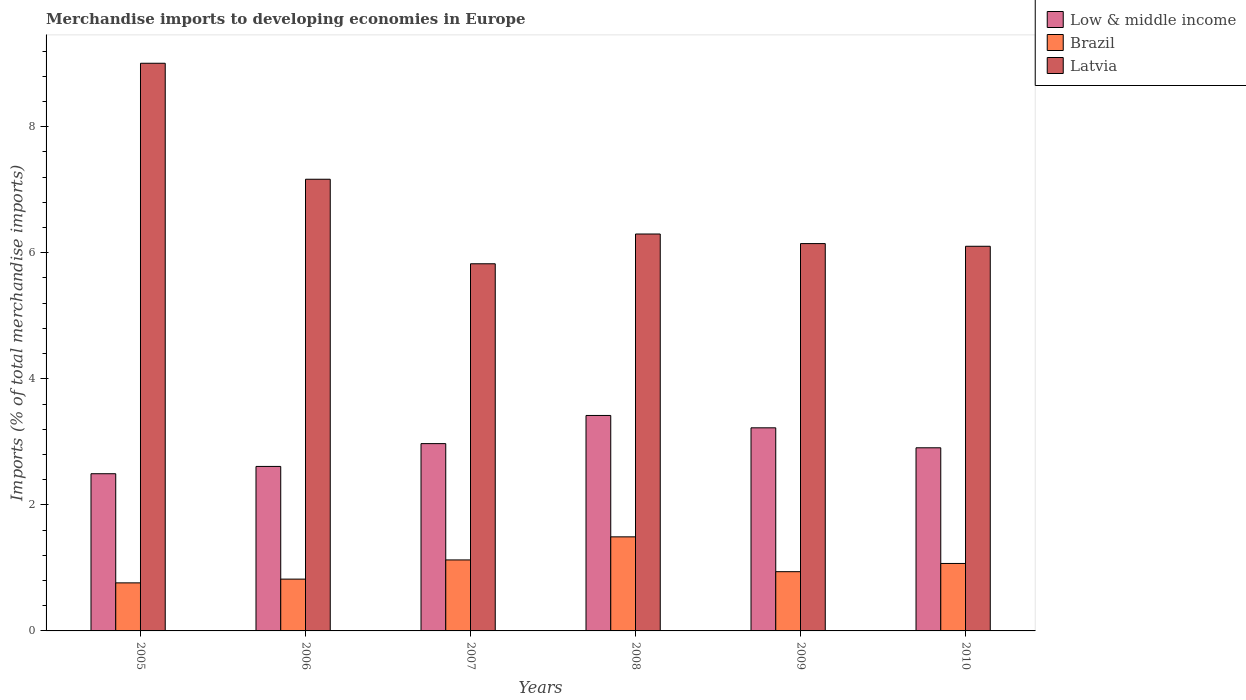How many groups of bars are there?
Give a very brief answer. 6. Are the number of bars per tick equal to the number of legend labels?
Your answer should be compact. Yes. How many bars are there on the 5th tick from the left?
Your answer should be very brief. 3. How many bars are there on the 2nd tick from the right?
Provide a short and direct response. 3. In how many cases, is the number of bars for a given year not equal to the number of legend labels?
Keep it short and to the point. 0. What is the percentage total merchandise imports in Latvia in 2009?
Your answer should be very brief. 6.15. Across all years, what is the maximum percentage total merchandise imports in Latvia?
Provide a succinct answer. 9.01. Across all years, what is the minimum percentage total merchandise imports in Brazil?
Your answer should be very brief. 0.76. In which year was the percentage total merchandise imports in Low & middle income maximum?
Make the answer very short. 2008. In which year was the percentage total merchandise imports in Latvia minimum?
Give a very brief answer. 2007. What is the total percentage total merchandise imports in Latvia in the graph?
Provide a succinct answer. 40.55. What is the difference between the percentage total merchandise imports in Brazil in 2006 and that in 2007?
Offer a terse response. -0.3. What is the difference between the percentage total merchandise imports in Brazil in 2007 and the percentage total merchandise imports in Low & middle income in 2008?
Make the answer very short. -2.29. What is the average percentage total merchandise imports in Latvia per year?
Your response must be concise. 6.76. In the year 2009, what is the difference between the percentage total merchandise imports in Low & middle income and percentage total merchandise imports in Brazil?
Give a very brief answer. 2.28. In how many years, is the percentage total merchandise imports in Brazil greater than 1.6 %?
Offer a very short reply. 0. What is the ratio of the percentage total merchandise imports in Low & middle income in 2007 to that in 2008?
Provide a short and direct response. 0.87. What is the difference between the highest and the second highest percentage total merchandise imports in Low & middle income?
Offer a very short reply. 0.2. What is the difference between the highest and the lowest percentage total merchandise imports in Brazil?
Your answer should be very brief. 0.73. In how many years, is the percentage total merchandise imports in Latvia greater than the average percentage total merchandise imports in Latvia taken over all years?
Provide a succinct answer. 2. What does the 2nd bar from the left in 2009 represents?
Provide a short and direct response. Brazil. What does the 3rd bar from the right in 2009 represents?
Your answer should be very brief. Low & middle income. Is it the case that in every year, the sum of the percentage total merchandise imports in Latvia and percentage total merchandise imports in Low & middle income is greater than the percentage total merchandise imports in Brazil?
Offer a terse response. Yes. How many years are there in the graph?
Give a very brief answer. 6. Does the graph contain any zero values?
Your answer should be very brief. No. Does the graph contain grids?
Offer a terse response. No. What is the title of the graph?
Keep it short and to the point. Merchandise imports to developing economies in Europe. What is the label or title of the X-axis?
Your answer should be compact. Years. What is the label or title of the Y-axis?
Keep it short and to the point. Imports (% of total merchandise imports). What is the Imports (% of total merchandise imports) in Low & middle income in 2005?
Provide a short and direct response. 2.49. What is the Imports (% of total merchandise imports) of Brazil in 2005?
Keep it short and to the point. 0.76. What is the Imports (% of total merchandise imports) in Latvia in 2005?
Ensure brevity in your answer.  9.01. What is the Imports (% of total merchandise imports) in Low & middle income in 2006?
Ensure brevity in your answer.  2.61. What is the Imports (% of total merchandise imports) in Brazil in 2006?
Your answer should be very brief. 0.82. What is the Imports (% of total merchandise imports) of Latvia in 2006?
Ensure brevity in your answer.  7.17. What is the Imports (% of total merchandise imports) in Low & middle income in 2007?
Make the answer very short. 2.97. What is the Imports (% of total merchandise imports) of Brazil in 2007?
Your response must be concise. 1.13. What is the Imports (% of total merchandise imports) of Latvia in 2007?
Offer a terse response. 5.83. What is the Imports (% of total merchandise imports) in Low & middle income in 2008?
Provide a succinct answer. 3.42. What is the Imports (% of total merchandise imports) in Brazil in 2008?
Provide a short and direct response. 1.49. What is the Imports (% of total merchandise imports) in Latvia in 2008?
Offer a terse response. 6.3. What is the Imports (% of total merchandise imports) of Low & middle income in 2009?
Your answer should be compact. 3.22. What is the Imports (% of total merchandise imports) in Brazil in 2009?
Keep it short and to the point. 0.94. What is the Imports (% of total merchandise imports) of Latvia in 2009?
Offer a terse response. 6.15. What is the Imports (% of total merchandise imports) of Low & middle income in 2010?
Your answer should be very brief. 2.91. What is the Imports (% of total merchandise imports) of Brazil in 2010?
Your answer should be very brief. 1.07. What is the Imports (% of total merchandise imports) of Latvia in 2010?
Give a very brief answer. 6.1. Across all years, what is the maximum Imports (% of total merchandise imports) in Low & middle income?
Make the answer very short. 3.42. Across all years, what is the maximum Imports (% of total merchandise imports) in Brazil?
Give a very brief answer. 1.49. Across all years, what is the maximum Imports (% of total merchandise imports) of Latvia?
Give a very brief answer. 9.01. Across all years, what is the minimum Imports (% of total merchandise imports) of Low & middle income?
Your answer should be compact. 2.49. Across all years, what is the minimum Imports (% of total merchandise imports) in Brazil?
Give a very brief answer. 0.76. Across all years, what is the minimum Imports (% of total merchandise imports) of Latvia?
Your response must be concise. 5.83. What is the total Imports (% of total merchandise imports) in Low & middle income in the graph?
Provide a succinct answer. 17.62. What is the total Imports (% of total merchandise imports) of Brazil in the graph?
Your answer should be very brief. 6.21. What is the total Imports (% of total merchandise imports) of Latvia in the graph?
Keep it short and to the point. 40.55. What is the difference between the Imports (% of total merchandise imports) of Low & middle income in 2005 and that in 2006?
Keep it short and to the point. -0.12. What is the difference between the Imports (% of total merchandise imports) of Brazil in 2005 and that in 2006?
Make the answer very short. -0.06. What is the difference between the Imports (% of total merchandise imports) of Latvia in 2005 and that in 2006?
Give a very brief answer. 1.84. What is the difference between the Imports (% of total merchandise imports) in Low & middle income in 2005 and that in 2007?
Your answer should be compact. -0.48. What is the difference between the Imports (% of total merchandise imports) in Brazil in 2005 and that in 2007?
Ensure brevity in your answer.  -0.36. What is the difference between the Imports (% of total merchandise imports) of Latvia in 2005 and that in 2007?
Keep it short and to the point. 3.18. What is the difference between the Imports (% of total merchandise imports) in Low & middle income in 2005 and that in 2008?
Keep it short and to the point. -0.92. What is the difference between the Imports (% of total merchandise imports) in Brazil in 2005 and that in 2008?
Your answer should be compact. -0.73. What is the difference between the Imports (% of total merchandise imports) of Latvia in 2005 and that in 2008?
Your answer should be compact. 2.71. What is the difference between the Imports (% of total merchandise imports) of Low & middle income in 2005 and that in 2009?
Offer a very short reply. -0.73. What is the difference between the Imports (% of total merchandise imports) in Brazil in 2005 and that in 2009?
Make the answer very short. -0.18. What is the difference between the Imports (% of total merchandise imports) in Latvia in 2005 and that in 2009?
Provide a short and direct response. 2.86. What is the difference between the Imports (% of total merchandise imports) of Low & middle income in 2005 and that in 2010?
Your answer should be compact. -0.41. What is the difference between the Imports (% of total merchandise imports) of Brazil in 2005 and that in 2010?
Keep it short and to the point. -0.31. What is the difference between the Imports (% of total merchandise imports) of Latvia in 2005 and that in 2010?
Ensure brevity in your answer.  2.9. What is the difference between the Imports (% of total merchandise imports) in Low & middle income in 2006 and that in 2007?
Give a very brief answer. -0.36. What is the difference between the Imports (% of total merchandise imports) in Brazil in 2006 and that in 2007?
Provide a succinct answer. -0.3. What is the difference between the Imports (% of total merchandise imports) in Latvia in 2006 and that in 2007?
Give a very brief answer. 1.34. What is the difference between the Imports (% of total merchandise imports) in Low & middle income in 2006 and that in 2008?
Your response must be concise. -0.81. What is the difference between the Imports (% of total merchandise imports) in Brazil in 2006 and that in 2008?
Offer a terse response. -0.67. What is the difference between the Imports (% of total merchandise imports) in Latvia in 2006 and that in 2008?
Ensure brevity in your answer.  0.87. What is the difference between the Imports (% of total merchandise imports) of Low & middle income in 2006 and that in 2009?
Your answer should be very brief. -0.61. What is the difference between the Imports (% of total merchandise imports) in Brazil in 2006 and that in 2009?
Your answer should be compact. -0.12. What is the difference between the Imports (% of total merchandise imports) in Latvia in 2006 and that in 2009?
Your answer should be very brief. 1.02. What is the difference between the Imports (% of total merchandise imports) of Low & middle income in 2006 and that in 2010?
Provide a short and direct response. -0.3. What is the difference between the Imports (% of total merchandise imports) of Brazil in 2006 and that in 2010?
Offer a terse response. -0.25. What is the difference between the Imports (% of total merchandise imports) of Latvia in 2006 and that in 2010?
Ensure brevity in your answer.  1.06. What is the difference between the Imports (% of total merchandise imports) of Low & middle income in 2007 and that in 2008?
Provide a succinct answer. -0.45. What is the difference between the Imports (% of total merchandise imports) of Brazil in 2007 and that in 2008?
Offer a very short reply. -0.37. What is the difference between the Imports (% of total merchandise imports) in Latvia in 2007 and that in 2008?
Your answer should be compact. -0.47. What is the difference between the Imports (% of total merchandise imports) of Low & middle income in 2007 and that in 2009?
Provide a succinct answer. -0.25. What is the difference between the Imports (% of total merchandise imports) in Brazil in 2007 and that in 2009?
Make the answer very short. 0.19. What is the difference between the Imports (% of total merchandise imports) in Latvia in 2007 and that in 2009?
Provide a short and direct response. -0.32. What is the difference between the Imports (% of total merchandise imports) of Low & middle income in 2007 and that in 2010?
Make the answer very short. 0.07. What is the difference between the Imports (% of total merchandise imports) in Brazil in 2007 and that in 2010?
Give a very brief answer. 0.06. What is the difference between the Imports (% of total merchandise imports) in Latvia in 2007 and that in 2010?
Make the answer very short. -0.28. What is the difference between the Imports (% of total merchandise imports) of Low & middle income in 2008 and that in 2009?
Your answer should be very brief. 0.2. What is the difference between the Imports (% of total merchandise imports) of Brazil in 2008 and that in 2009?
Give a very brief answer. 0.55. What is the difference between the Imports (% of total merchandise imports) of Latvia in 2008 and that in 2009?
Ensure brevity in your answer.  0.15. What is the difference between the Imports (% of total merchandise imports) of Low & middle income in 2008 and that in 2010?
Keep it short and to the point. 0.51. What is the difference between the Imports (% of total merchandise imports) of Brazil in 2008 and that in 2010?
Make the answer very short. 0.42. What is the difference between the Imports (% of total merchandise imports) of Latvia in 2008 and that in 2010?
Provide a short and direct response. 0.19. What is the difference between the Imports (% of total merchandise imports) in Low & middle income in 2009 and that in 2010?
Your response must be concise. 0.32. What is the difference between the Imports (% of total merchandise imports) of Brazil in 2009 and that in 2010?
Give a very brief answer. -0.13. What is the difference between the Imports (% of total merchandise imports) in Latvia in 2009 and that in 2010?
Offer a very short reply. 0.04. What is the difference between the Imports (% of total merchandise imports) in Low & middle income in 2005 and the Imports (% of total merchandise imports) in Brazil in 2006?
Your response must be concise. 1.67. What is the difference between the Imports (% of total merchandise imports) in Low & middle income in 2005 and the Imports (% of total merchandise imports) in Latvia in 2006?
Your answer should be compact. -4.67. What is the difference between the Imports (% of total merchandise imports) in Brazil in 2005 and the Imports (% of total merchandise imports) in Latvia in 2006?
Your answer should be compact. -6.4. What is the difference between the Imports (% of total merchandise imports) in Low & middle income in 2005 and the Imports (% of total merchandise imports) in Brazil in 2007?
Make the answer very short. 1.37. What is the difference between the Imports (% of total merchandise imports) of Low & middle income in 2005 and the Imports (% of total merchandise imports) of Latvia in 2007?
Your answer should be very brief. -3.33. What is the difference between the Imports (% of total merchandise imports) of Brazil in 2005 and the Imports (% of total merchandise imports) of Latvia in 2007?
Your answer should be very brief. -5.06. What is the difference between the Imports (% of total merchandise imports) of Low & middle income in 2005 and the Imports (% of total merchandise imports) of Latvia in 2008?
Offer a terse response. -3.8. What is the difference between the Imports (% of total merchandise imports) of Brazil in 2005 and the Imports (% of total merchandise imports) of Latvia in 2008?
Your answer should be compact. -5.54. What is the difference between the Imports (% of total merchandise imports) in Low & middle income in 2005 and the Imports (% of total merchandise imports) in Brazil in 2009?
Keep it short and to the point. 1.55. What is the difference between the Imports (% of total merchandise imports) in Low & middle income in 2005 and the Imports (% of total merchandise imports) in Latvia in 2009?
Give a very brief answer. -3.65. What is the difference between the Imports (% of total merchandise imports) of Brazil in 2005 and the Imports (% of total merchandise imports) of Latvia in 2009?
Ensure brevity in your answer.  -5.38. What is the difference between the Imports (% of total merchandise imports) in Low & middle income in 2005 and the Imports (% of total merchandise imports) in Brazil in 2010?
Keep it short and to the point. 1.42. What is the difference between the Imports (% of total merchandise imports) of Low & middle income in 2005 and the Imports (% of total merchandise imports) of Latvia in 2010?
Offer a very short reply. -3.61. What is the difference between the Imports (% of total merchandise imports) in Brazil in 2005 and the Imports (% of total merchandise imports) in Latvia in 2010?
Keep it short and to the point. -5.34. What is the difference between the Imports (% of total merchandise imports) of Low & middle income in 2006 and the Imports (% of total merchandise imports) of Brazil in 2007?
Offer a very short reply. 1.48. What is the difference between the Imports (% of total merchandise imports) in Low & middle income in 2006 and the Imports (% of total merchandise imports) in Latvia in 2007?
Ensure brevity in your answer.  -3.22. What is the difference between the Imports (% of total merchandise imports) of Brazil in 2006 and the Imports (% of total merchandise imports) of Latvia in 2007?
Provide a short and direct response. -5. What is the difference between the Imports (% of total merchandise imports) in Low & middle income in 2006 and the Imports (% of total merchandise imports) in Brazil in 2008?
Ensure brevity in your answer.  1.12. What is the difference between the Imports (% of total merchandise imports) in Low & middle income in 2006 and the Imports (% of total merchandise imports) in Latvia in 2008?
Keep it short and to the point. -3.69. What is the difference between the Imports (% of total merchandise imports) in Brazil in 2006 and the Imports (% of total merchandise imports) in Latvia in 2008?
Your answer should be compact. -5.48. What is the difference between the Imports (% of total merchandise imports) in Low & middle income in 2006 and the Imports (% of total merchandise imports) in Brazil in 2009?
Give a very brief answer. 1.67. What is the difference between the Imports (% of total merchandise imports) in Low & middle income in 2006 and the Imports (% of total merchandise imports) in Latvia in 2009?
Your response must be concise. -3.54. What is the difference between the Imports (% of total merchandise imports) in Brazil in 2006 and the Imports (% of total merchandise imports) in Latvia in 2009?
Make the answer very short. -5.32. What is the difference between the Imports (% of total merchandise imports) in Low & middle income in 2006 and the Imports (% of total merchandise imports) in Brazil in 2010?
Provide a succinct answer. 1.54. What is the difference between the Imports (% of total merchandise imports) in Low & middle income in 2006 and the Imports (% of total merchandise imports) in Latvia in 2010?
Your answer should be compact. -3.49. What is the difference between the Imports (% of total merchandise imports) of Brazil in 2006 and the Imports (% of total merchandise imports) of Latvia in 2010?
Your answer should be compact. -5.28. What is the difference between the Imports (% of total merchandise imports) of Low & middle income in 2007 and the Imports (% of total merchandise imports) of Brazil in 2008?
Ensure brevity in your answer.  1.48. What is the difference between the Imports (% of total merchandise imports) in Low & middle income in 2007 and the Imports (% of total merchandise imports) in Latvia in 2008?
Provide a succinct answer. -3.33. What is the difference between the Imports (% of total merchandise imports) in Brazil in 2007 and the Imports (% of total merchandise imports) in Latvia in 2008?
Your answer should be very brief. -5.17. What is the difference between the Imports (% of total merchandise imports) in Low & middle income in 2007 and the Imports (% of total merchandise imports) in Brazil in 2009?
Your answer should be very brief. 2.03. What is the difference between the Imports (% of total merchandise imports) of Low & middle income in 2007 and the Imports (% of total merchandise imports) of Latvia in 2009?
Provide a short and direct response. -3.17. What is the difference between the Imports (% of total merchandise imports) of Brazil in 2007 and the Imports (% of total merchandise imports) of Latvia in 2009?
Keep it short and to the point. -5.02. What is the difference between the Imports (% of total merchandise imports) of Low & middle income in 2007 and the Imports (% of total merchandise imports) of Brazil in 2010?
Make the answer very short. 1.9. What is the difference between the Imports (% of total merchandise imports) of Low & middle income in 2007 and the Imports (% of total merchandise imports) of Latvia in 2010?
Your answer should be very brief. -3.13. What is the difference between the Imports (% of total merchandise imports) of Brazil in 2007 and the Imports (% of total merchandise imports) of Latvia in 2010?
Keep it short and to the point. -4.98. What is the difference between the Imports (% of total merchandise imports) in Low & middle income in 2008 and the Imports (% of total merchandise imports) in Brazil in 2009?
Provide a succinct answer. 2.48. What is the difference between the Imports (% of total merchandise imports) of Low & middle income in 2008 and the Imports (% of total merchandise imports) of Latvia in 2009?
Offer a very short reply. -2.73. What is the difference between the Imports (% of total merchandise imports) of Brazil in 2008 and the Imports (% of total merchandise imports) of Latvia in 2009?
Ensure brevity in your answer.  -4.65. What is the difference between the Imports (% of total merchandise imports) of Low & middle income in 2008 and the Imports (% of total merchandise imports) of Brazil in 2010?
Provide a succinct answer. 2.35. What is the difference between the Imports (% of total merchandise imports) of Low & middle income in 2008 and the Imports (% of total merchandise imports) of Latvia in 2010?
Offer a terse response. -2.68. What is the difference between the Imports (% of total merchandise imports) in Brazil in 2008 and the Imports (% of total merchandise imports) in Latvia in 2010?
Your answer should be very brief. -4.61. What is the difference between the Imports (% of total merchandise imports) in Low & middle income in 2009 and the Imports (% of total merchandise imports) in Brazil in 2010?
Ensure brevity in your answer.  2.15. What is the difference between the Imports (% of total merchandise imports) of Low & middle income in 2009 and the Imports (% of total merchandise imports) of Latvia in 2010?
Keep it short and to the point. -2.88. What is the difference between the Imports (% of total merchandise imports) in Brazil in 2009 and the Imports (% of total merchandise imports) in Latvia in 2010?
Provide a short and direct response. -5.16. What is the average Imports (% of total merchandise imports) of Low & middle income per year?
Offer a very short reply. 2.94. What is the average Imports (% of total merchandise imports) of Brazil per year?
Your answer should be compact. 1.04. What is the average Imports (% of total merchandise imports) of Latvia per year?
Your response must be concise. 6.76. In the year 2005, what is the difference between the Imports (% of total merchandise imports) in Low & middle income and Imports (% of total merchandise imports) in Brazil?
Offer a very short reply. 1.73. In the year 2005, what is the difference between the Imports (% of total merchandise imports) in Low & middle income and Imports (% of total merchandise imports) in Latvia?
Offer a terse response. -6.51. In the year 2005, what is the difference between the Imports (% of total merchandise imports) in Brazil and Imports (% of total merchandise imports) in Latvia?
Provide a short and direct response. -8.24. In the year 2006, what is the difference between the Imports (% of total merchandise imports) of Low & middle income and Imports (% of total merchandise imports) of Brazil?
Provide a short and direct response. 1.79. In the year 2006, what is the difference between the Imports (% of total merchandise imports) of Low & middle income and Imports (% of total merchandise imports) of Latvia?
Offer a terse response. -4.56. In the year 2006, what is the difference between the Imports (% of total merchandise imports) in Brazil and Imports (% of total merchandise imports) in Latvia?
Provide a short and direct response. -6.34. In the year 2007, what is the difference between the Imports (% of total merchandise imports) in Low & middle income and Imports (% of total merchandise imports) in Brazil?
Keep it short and to the point. 1.85. In the year 2007, what is the difference between the Imports (% of total merchandise imports) in Low & middle income and Imports (% of total merchandise imports) in Latvia?
Make the answer very short. -2.85. In the year 2007, what is the difference between the Imports (% of total merchandise imports) of Brazil and Imports (% of total merchandise imports) of Latvia?
Ensure brevity in your answer.  -4.7. In the year 2008, what is the difference between the Imports (% of total merchandise imports) in Low & middle income and Imports (% of total merchandise imports) in Brazil?
Provide a short and direct response. 1.93. In the year 2008, what is the difference between the Imports (% of total merchandise imports) of Low & middle income and Imports (% of total merchandise imports) of Latvia?
Offer a terse response. -2.88. In the year 2008, what is the difference between the Imports (% of total merchandise imports) in Brazil and Imports (% of total merchandise imports) in Latvia?
Provide a succinct answer. -4.81. In the year 2009, what is the difference between the Imports (% of total merchandise imports) of Low & middle income and Imports (% of total merchandise imports) of Brazil?
Give a very brief answer. 2.28. In the year 2009, what is the difference between the Imports (% of total merchandise imports) in Low & middle income and Imports (% of total merchandise imports) in Latvia?
Provide a succinct answer. -2.92. In the year 2009, what is the difference between the Imports (% of total merchandise imports) of Brazil and Imports (% of total merchandise imports) of Latvia?
Offer a terse response. -5.21. In the year 2010, what is the difference between the Imports (% of total merchandise imports) in Low & middle income and Imports (% of total merchandise imports) in Brazil?
Give a very brief answer. 1.84. In the year 2010, what is the difference between the Imports (% of total merchandise imports) of Low & middle income and Imports (% of total merchandise imports) of Latvia?
Your answer should be compact. -3.2. In the year 2010, what is the difference between the Imports (% of total merchandise imports) in Brazil and Imports (% of total merchandise imports) in Latvia?
Your answer should be compact. -5.03. What is the ratio of the Imports (% of total merchandise imports) in Low & middle income in 2005 to that in 2006?
Keep it short and to the point. 0.96. What is the ratio of the Imports (% of total merchandise imports) of Brazil in 2005 to that in 2006?
Offer a very short reply. 0.93. What is the ratio of the Imports (% of total merchandise imports) of Latvia in 2005 to that in 2006?
Your answer should be compact. 1.26. What is the ratio of the Imports (% of total merchandise imports) of Low & middle income in 2005 to that in 2007?
Your response must be concise. 0.84. What is the ratio of the Imports (% of total merchandise imports) in Brazil in 2005 to that in 2007?
Offer a terse response. 0.68. What is the ratio of the Imports (% of total merchandise imports) in Latvia in 2005 to that in 2007?
Give a very brief answer. 1.55. What is the ratio of the Imports (% of total merchandise imports) of Low & middle income in 2005 to that in 2008?
Your answer should be compact. 0.73. What is the ratio of the Imports (% of total merchandise imports) of Brazil in 2005 to that in 2008?
Provide a short and direct response. 0.51. What is the ratio of the Imports (% of total merchandise imports) in Latvia in 2005 to that in 2008?
Make the answer very short. 1.43. What is the ratio of the Imports (% of total merchandise imports) in Low & middle income in 2005 to that in 2009?
Keep it short and to the point. 0.77. What is the ratio of the Imports (% of total merchandise imports) of Brazil in 2005 to that in 2009?
Your response must be concise. 0.81. What is the ratio of the Imports (% of total merchandise imports) of Latvia in 2005 to that in 2009?
Ensure brevity in your answer.  1.47. What is the ratio of the Imports (% of total merchandise imports) of Low & middle income in 2005 to that in 2010?
Keep it short and to the point. 0.86. What is the ratio of the Imports (% of total merchandise imports) of Brazil in 2005 to that in 2010?
Give a very brief answer. 0.71. What is the ratio of the Imports (% of total merchandise imports) of Latvia in 2005 to that in 2010?
Make the answer very short. 1.48. What is the ratio of the Imports (% of total merchandise imports) in Low & middle income in 2006 to that in 2007?
Make the answer very short. 0.88. What is the ratio of the Imports (% of total merchandise imports) in Brazil in 2006 to that in 2007?
Your response must be concise. 0.73. What is the ratio of the Imports (% of total merchandise imports) of Latvia in 2006 to that in 2007?
Ensure brevity in your answer.  1.23. What is the ratio of the Imports (% of total merchandise imports) of Low & middle income in 2006 to that in 2008?
Give a very brief answer. 0.76. What is the ratio of the Imports (% of total merchandise imports) in Brazil in 2006 to that in 2008?
Your answer should be compact. 0.55. What is the ratio of the Imports (% of total merchandise imports) in Latvia in 2006 to that in 2008?
Your answer should be very brief. 1.14. What is the ratio of the Imports (% of total merchandise imports) of Low & middle income in 2006 to that in 2009?
Offer a very short reply. 0.81. What is the ratio of the Imports (% of total merchandise imports) of Brazil in 2006 to that in 2009?
Ensure brevity in your answer.  0.87. What is the ratio of the Imports (% of total merchandise imports) in Latvia in 2006 to that in 2009?
Provide a succinct answer. 1.17. What is the ratio of the Imports (% of total merchandise imports) of Low & middle income in 2006 to that in 2010?
Give a very brief answer. 0.9. What is the ratio of the Imports (% of total merchandise imports) in Brazil in 2006 to that in 2010?
Give a very brief answer. 0.77. What is the ratio of the Imports (% of total merchandise imports) in Latvia in 2006 to that in 2010?
Offer a very short reply. 1.17. What is the ratio of the Imports (% of total merchandise imports) of Low & middle income in 2007 to that in 2008?
Provide a succinct answer. 0.87. What is the ratio of the Imports (% of total merchandise imports) in Brazil in 2007 to that in 2008?
Your answer should be compact. 0.75. What is the ratio of the Imports (% of total merchandise imports) in Latvia in 2007 to that in 2008?
Give a very brief answer. 0.93. What is the ratio of the Imports (% of total merchandise imports) in Low & middle income in 2007 to that in 2009?
Ensure brevity in your answer.  0.92. What is the ratio of the Imports (% of total merchandise imports) in Brazil in 2007 to that in 2009?
Offer a terse response. 1.2. What is the ratio of the Imports (% of total merchandise imports) of Latvia in 2007 to that in 2009?
Your answer should be very brief. 0.95. What is the ratio of the Imports (% of total merchandise imports) in Low & middle income in 2007 to that in 2010?
Keep it short and to the point. 1.02. What is the ratio of the Imports (% of total merchandise imports) of Brazil in 2007 to that in 2010?
Keep it short and to the point. 1.05. What is the ratio of the Imports (% of total merchandise imports) in Latvia in 2007 to that in 2010?
Your answer should be compact. 0.95. What is the ratio of the Imports (% of total merchandise imports) of Low & middle income in 2008 to that in 2009?
Make the answer very short. 1.06. What is the ratio of the Imports (% of total merchandise imports) in Brazil in 2008 to that in 2009?
Your response must be concise. 1.59. What is the ratio of the Imports (% of total merchandise imports) in Latvia in 2008 to that in 2009?
Your answer should be very brief. 1.02. What is the ratio of the Imports (% of total merchandise imports) of Low & middle income in 2008 to that in 2010?
Provide a succinct answer. 1.18. What is the ratio of the Imports (% of total merchandise imports) in Brazil in 2008 to that in 2010?
Make the answer very short. 1.39. What is the ratio of the Imports (% of total merchandise imports) of Latvia in 2008 to that in 2010?
Make the answer very short. 1.03. What is the ratio of the Imports (% of total merchandise imports) of Low & middle income in 2009 to that in 2010?
Make the answer very short. 1.11. What is the ratio of the Imports (% of total merchandise imports) of Brazil in 2009 to that in 2010?
Provide a short and direct response. 0.88. What is the ratio of the Imports (% of total merchandise imports) in Latvia in 2009 to that in 2010?
Your answer should be compact. 1.01. What is the difference between the highest and the second highest Imports (% of total merchandise imports) in Low & middle income?
Give a very brief answer. 0.2. What is the difference between the highest and the second highest Imports (% of total merchandise imports) of Brazil?
Your answer should be compact. 0.37. What is the difference between the highest and the second highest Imports (% of total merchandise imports) of Latvia?
Give a very brief answer. 1.84. What is the difference between the highest and the lowest Imports (% of total merchandise imports) in Low & middle income?
Make the answer very short. 0.92. What is the difference between the highest and the lowest Imports (% of total merchandise imports) of Brazil?
Ensure brevity in your answer.  0.73. What is the difference between the highest and the lowest Imports (% of total merchandise imports) of Latvia?
Your answer should be compact. 3.18. 